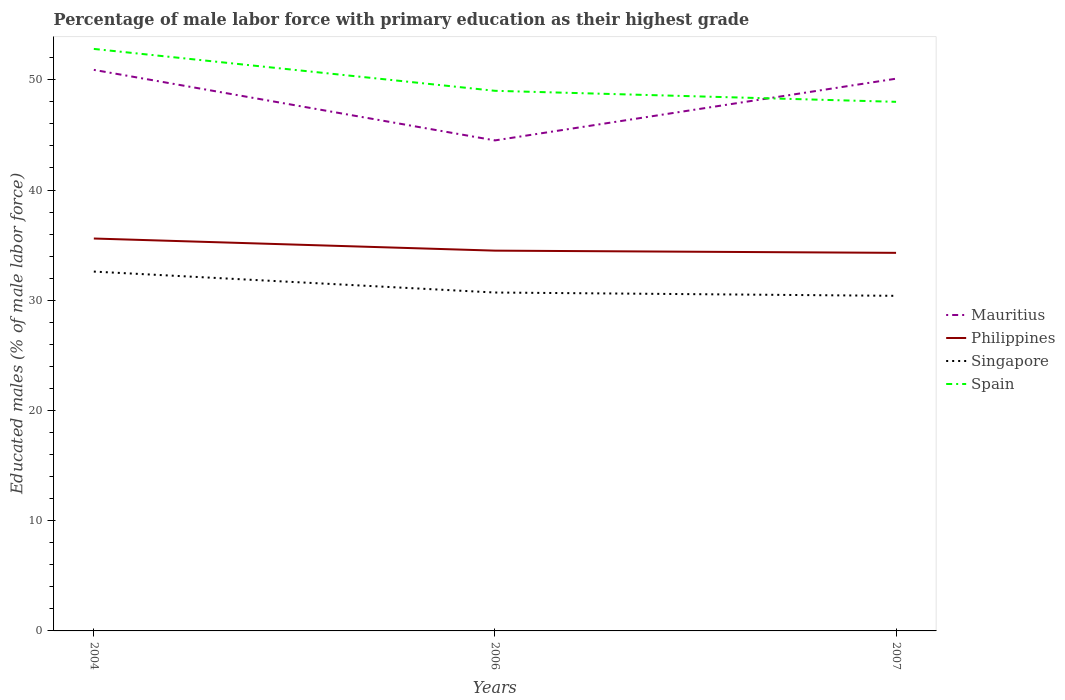How many different coloured lines are there?
Keep it short and to the point. 4. Across all years, what is the maximum percentage of male labor force with primary education in Singapore?
Keep it short and to the point. 30.4. What is the total percentage of male labor force with primary education in Mauritius in the graph?
Your answer should be compact. 0.8. What is the difference between the highest and the second highest percentage of male labor force with primary education in Mauritius?
Provide a short and direct response. 6.4. What is the difference between the highest and the lowest percentage of male labor force with primary education in Singapore?
Your answer should be very brief. 1. Is the percentage of male labor force with primary education in Spain strictly greater than the percentage of male labor force with primary education in Singapore over the years?
Offer a terse response. No. How many lines are there?
Keep it short and to the point. 4. Does the graph contain any zero values?
Ensure brevity in your answer.  No. Does the graph contain grids?
Provide a succinct answer. No. Where does the legend appear in the graph?
Your answer should be very brief. Center right. What is the title of the graph?
Provide a succinct answer. Percentage of male labor force with primary education as their highest grade. Does "Chad" appear as one of the legend labels in the graph?
Keep it short and to the point. No. What is the label or title of the Y-axis?
Keep it short and to the point. Educated males (% of male labor force). What is the Educated males (% of male labor force) of Mauritius in 2004?
Make the answer very short. 50.9. What is the Educated males (% of male labor force) of Philippines in 2004?
Offer a very short reply. 35.6. What is the Educated males (% of male labor force) in Singapore in 2004?
Your response must be concise. 32.6. What is the Educated males (% of male labor force) in Spain in 2004?
Keep it short and to the point. 52.8. What is the Educated males (% of male labor force) of Mauritius in 2006?
Provide a succinct answer. 44.5. What is the Educated males (% of male labor force) of Philippines in 2006?
Provide a short and direct response. 34.5. What is the Educated males (% of male labor force) in Singapore in 2006?
Your answer should be compact. 30.7. What is the Educated males (% of male labor force) in Mauritius in 2007?
Give a very brief answer. 50.1. What is the Educated males (% of male labor force) in Philippines in 2007?
Offer a terse response. 34.3. What is the Educated males (% of male labor force) of Singapore in 2007?
Give a very brief answer. 30.4. What is the Educated males (% of male labor force) of Spain in 2007?
Provide a short and direct response. 48. Across all years, what is the maximum Educated males (% of male labor force) of Mauritius?
Offer a very short reply. 50.9. Across all years, what is the maximum Educated males (% of male labor force) in Philippines?
Give a very brief answer. 35.6. Across all years, what is the maximum Educated males (% of male labor force) in Singapore?
Your answer should be compact. 32.6. Across all years, what is the maximum Educated males (% of male labor force) of Spain?
Provide a short and direct response. 52.8. Across all years, what is the minimum Educated males (% of male labor force) in Mauritius?
Ensure brevity in your answer.  44.5. Across all years, what is the minimum Educated males (% of male labor force) of Philippines?
Keep it short and to the point. 34.3. Across all years, what is the minimum Educated males (% of male labor force) in Singapore?
Ensure brevity in your answer.  30.4. What is the total Educated males (% of male labor force) of Mauritius in the graph?
Make the answer very short. 145.5. What is the total Educated males (% of male labor force) of Philippines in the graph?
Make the answer very short. 104.4. What is the total Educated males (% of male labor force) of Singapore in the graph?
Offer a terse response. 93.7. What is the total Educated males (% of male labor force) in Spain in the graph?
Offer a terse response. 149.8. What is the difference between the Educated males (% of male labor force) in Mauritius in 2004 and that in 2006?
Offer a very short reply. 6.4. What is the difference between the Educated males (% of male labor force) of Singapore in 2004 and that in 2006?
Provide a succinct answer. 1.9. What is the difference between the Educated males (% of male labor force) of Mauritius in 2004 and that in 2007?
Ensure brevity in your answer.  0.8. What is the difference between the Educated males (% of male labor force) of Singapore in 2004 and that in 2007?
Your answer should be very brief. 2.2. What is the difference between the Educated males (% of male labor force) in Philippines in 2006 and that in 2007?
Keep it short and to the point. 0.2. What is the difference between the Educated males (% of male labor force) of Mauritius in 2004 and the Educated males (% of male labor force) of Singapore in 2006?
Give a very brief answer. 20.2. What is the difference between the Educated males (% of male labor force) in Philippines in 2004 and the Educated males (% of male labor force) in Singapore in 2006?
Provide a succinct answer. 4.9. What is the difference between the Educated males (% of male labor force) of Philippines in 2004 and the Educated males (% of male labor force) of Spain in 2006?
Provide a succinct answer. -13.4. What is the difference between the Educated males (% of male labor force) of Singapore in 2004 and the Educated males (% of male labor force) of Spain in 2006?
Provide a short and direct response. -16.4. What is the difference between the Educated males (% of male labor force) of Mauritius in 2004 and the Educated males (% of male labor force) of Philippines in 2007?
Give a very brief answer. 16.6. What is the difference between the Educated males (% of male labor force) of Mauritius in 2004 and the Educated males (% of male labor force) of Spain in 2007?
Offer a terse response. 2.9. What is the difference between the Educated males (% of male labor force) of Singapore in 2004 and the Educated males (% of male labor force) of Spain in 2007?
Offer a very short reply. -15.4. What is the difference between the Educated males (% of male labor force) of Mauritius in 2006 and the Educated males (% of male labor force) of Philippines in 2007?
Your answer should be compact. 10.2. What is the difference between the Educated males (% of male labor force) in Singapore in 2006 and the Educated males (% of male labor force) in Spain in 2007?
Provide a succinct answer. -17.3. What is the average Educated males (% of male labor force) in Mauritius per year?
Your answer should be compact. 48.5. What is the average Educated males (% of male labor force) of Philippines per year?
Offer a terse response. 34.8. What is the average Educated males (% of male labor force) of Singapore per year?
Offer a terse response. 31.23. What is the average Educated males (% of male labor force) in Spain per year?
Offer a very short reply. 49.93. In the year 2004, what is the difference between the Educated males (% of male labor force) in Mauritius and Educated males (% of male labor force) in Philippines?
Offer a terse response. 15.3. In the year 2004, what is the difference between the Educated males (% of male labor force) of Mauritius and Educated males (% of male labor force) of Spain?
Ensure brevity in your answer.  -1.9. In the year 2004, what is the difference between the Educated males (% of male labor force) of Philippines and Educated males (% of male labor force) of Spain?
Your answer should be compact. -17.2. In the year 2004, what is the difference between the Educated males (% of male labor force) in Singapore and Educated males (% of male labor force) in Spain?
Keep it short and to the point. -20.2. In the year 2006, what is the difference between the Educated males (% of male labor force) of Mauritius and Educated males (% of male labor force) of Singapore?
Offer a very short reply. 13.8. In the year 2006, what is the difference between the Educated males (% of male labor force) of Singapore and Educated males (% of male labor force) of Spain?
Your answer should be compact. -18.3. In the year 2007, what is the difference between the Educated males (% of male labor force) in Mauritius and Educated males (% of male labor force) in Singapore?
Provide a succinct answer. 19.7. In the year 2007, what is the difference between the Educated males (% of male labor force) of Mauritius and Educated males (% of male labor force) of Spain?
Give a very brief answer. 2.1. In the year 2007, what is the difference between the Educated males (% of male labor force) in Philippines and Educated males (% of male labor force) in Spain?
Provide a short and direct response. -13.7. In the year 2007, what is the difference between the Educated males (% of male labor force) of Singapore and Educated males (% of male labor force) of Spain?
Give a very brief answer. -17.6. What is the ratio of the Educated males (% of male labor force) of Mauritius in 2004 to that in 2006?
Your answer should be compact. 1.14. What is the ratio of the Educated males (% of male labor force) in Philippines in 2004 to that in 2006?
Provide a succinct answer. 1.03. What is the ratio of the Educated males (% of male labor force) in Singapore in 2004 to that in 2006?
Your response must be concise. 1.06. What is the ratio of the Educated males (% of male labor force) in Spain in 2004 to that in 2006?
Ensure brevity in your answer.  1.08. What is the ratio of the Educated males (% of male labor force) of Mauritius in 2004 to that in 2007?
Your response must be concise. 1.02. What is the ratio of the Educated males (% of male labor force) in Philippines in 2004 to that in 2007?
Offer a terse response. 1.04. What is the ratio of the Educated males (% of male labor force) in Singapore in 2004 to that in 2007?
Provide a succinct answer. 1.07. What is the ratio of the Educated males (% of male labor force) of Mauritius in 2006 to that in 2007?
Keep it short and to the point. 0.89. What is the ratio of the Educated males (% of male labor force) of Philippines in 2006 to that in 2007?
Provide a short and direct response. 1.01. What is the ratio of the Educated males (% of male labor force) in Singapore in 2006 to that in 2007?
Offer a terse response. 1.01. What is the ratio of the Educated males (% of male labor force) in Spain in 2006 to that in 2007?
Keep it short and to the point. 1.02. What is the difference between the highest and the second highest Educated males (% of male labor force) of Mauritius?
Give a very brief answer. 0.8. What is the difference between the highest and the second highest Educated males (% of male labor force) in Philippines?
Your response must be concise. 1.1. What is the difference between the highest and the lowest Educated males (% of male labor force) in Spain?
Your response must be concise. 4.8. 